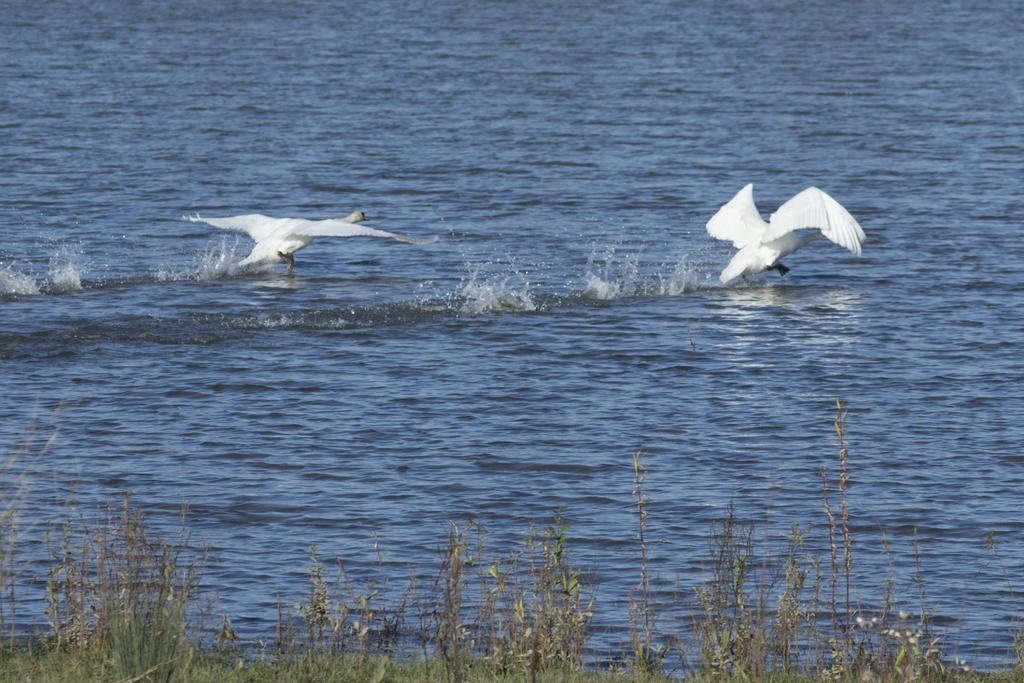How many birds are present in the image? There are two birds in the image. What color are the birds? The birds are white in color. What else can be seen in the image besides the birds? There are plants and water visible in the image. What is the color of the water? The water is blue in color. Can you read the statement written by the ladybug in the image? There is no ladybug present in the image, and therefore no statement can be read. 